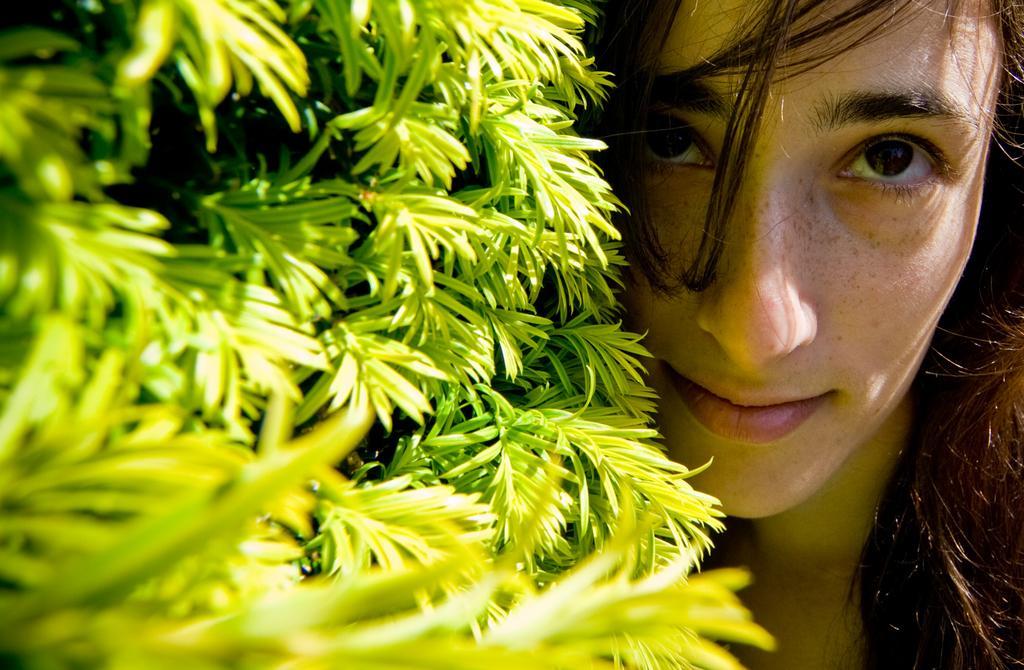Describe this image in one or two sentences. In this picture we can see a woman and on the left side of the picture we can see green leaves. 